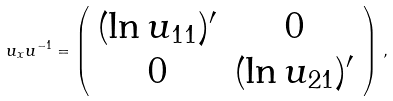<formula> <loc_0><loc_0><loc_500><loc_500>u _ { x } u ^ { - 1 } = \left ( \begin{array} { c c } ( \ln u _ { 1 1 } ) ^ { \prime } & 0 \\ 0 & ( \ln u _ { 2 1 } ) ^ { \prime } \end{array} \right ) \, ,</formula> 